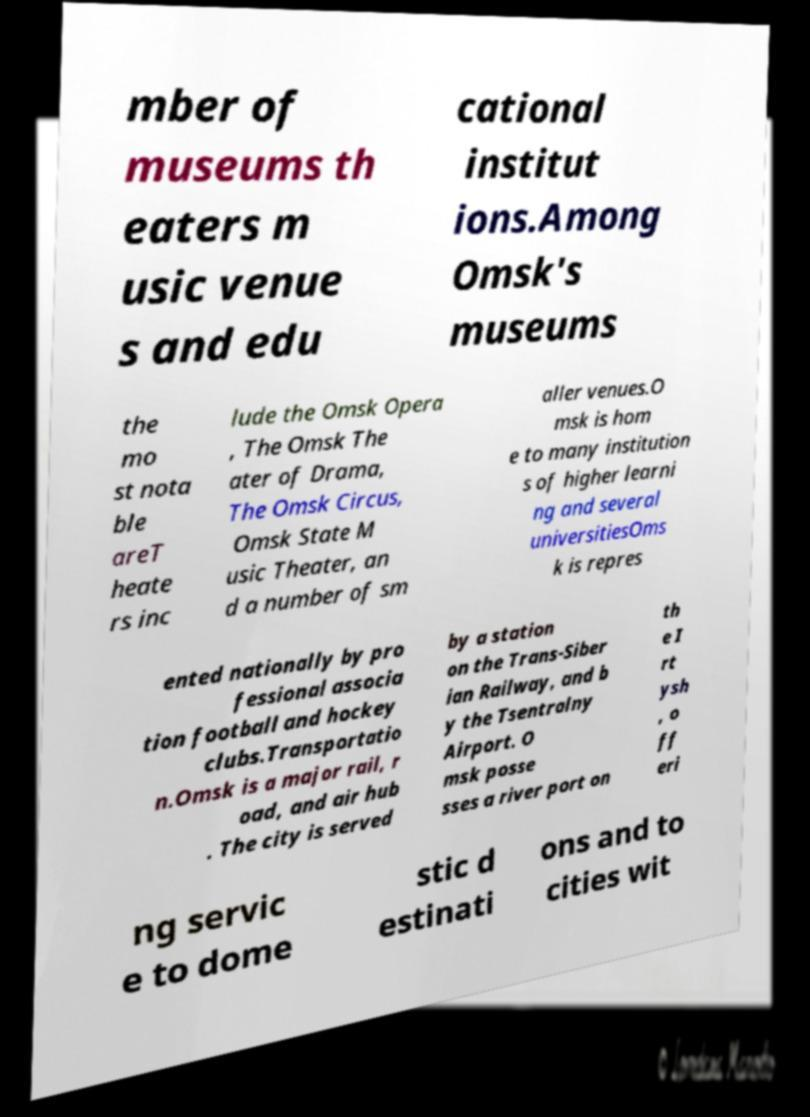What messages or text are displayed in this image? I need them in a readable, typed format. mber of museums th eaters m usic venue s and edu cational institut ions.Among Omsk's museums the mo st nota ble areT heate rs inc lude the Omsk Opera , The Omsk The ater of Drama, The Omsk Circus, Omsk State M usic Theater, an d a number of sm aller venues.O msk is hom e to many institution s of higher learni ng and several universitiesOms k is repres ented nationally by pro fessional associa tion football and hockey clubs.Transportatio n.Omsk is a major rail, r oad, and air hub . The city is served by a station on the Trans-Siber ian Railway, and b y the Tsentralny Airport. O msk posse sses a river port on th e I rt ysh , o ff eri ng servic e to dome stic d estinati ons and to cities wit 